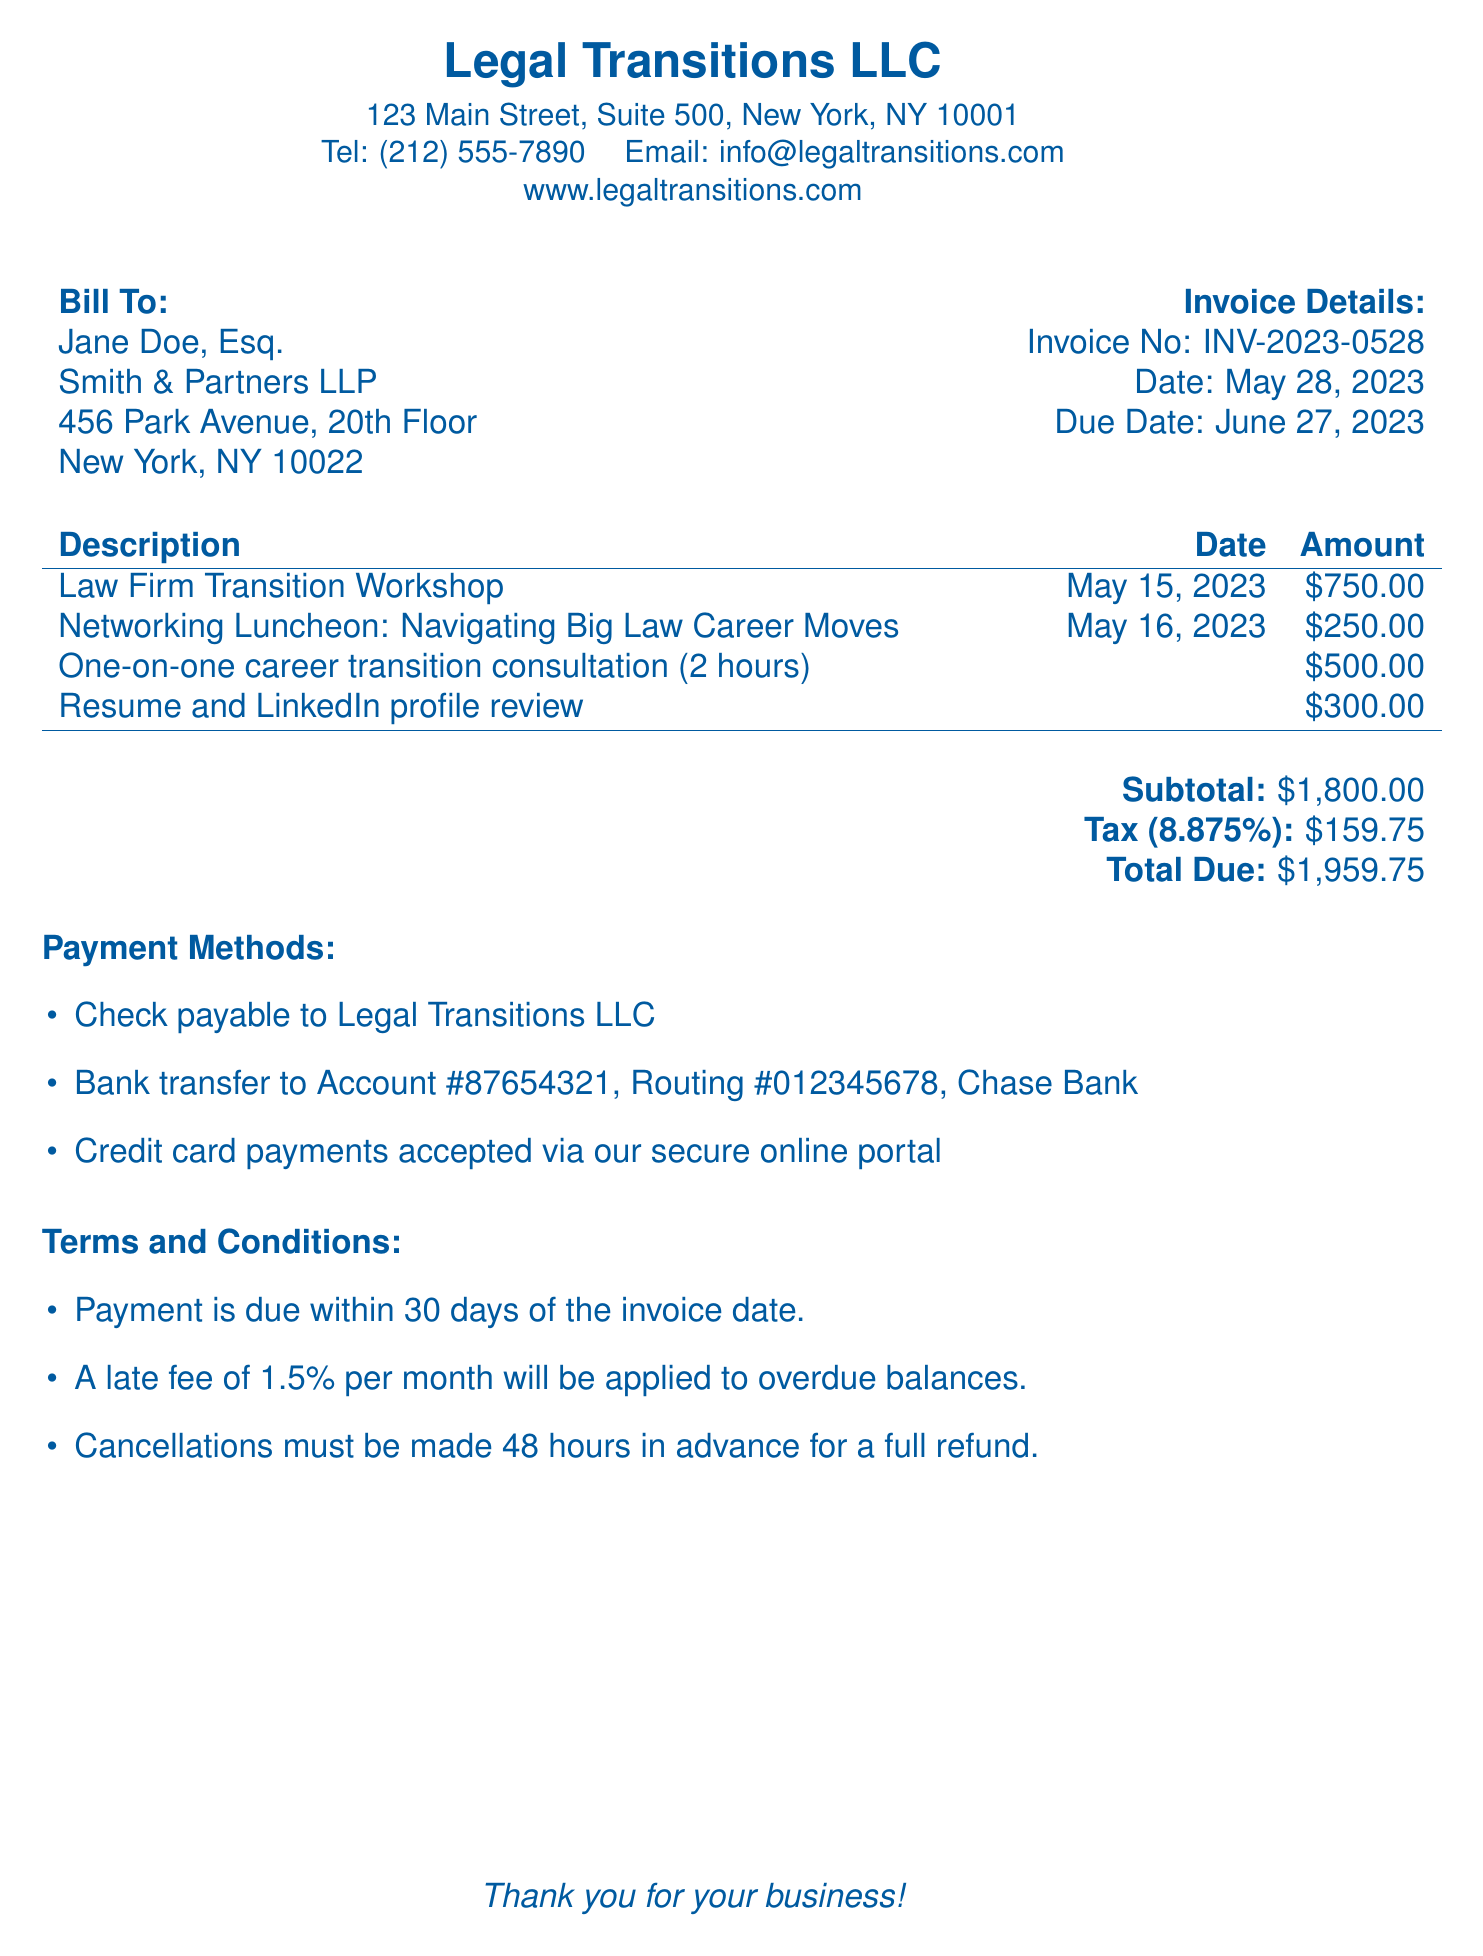What is the invoice number? The invoice number is found in the invoice details section of the document.
Answer: INV-2023-0528 Who is the bill recipient? The bill recipient is the individual or entity listed in the "Bill To" section.
Answer: Jane Doe, Esq What is the total amount due? The total amount due is calculated at the end of the invoice after adding the subtotal and tax.
Answer: $1,959.75 When is the due date for payment? The due date is specified in the invoice details section.
Answer: June 27, 2023 What is the amount for the Law Firm Transition Workshop? The amount for the workshop is listed under the description section.
Answer: $750.00 What is the tax rate applied to the subtotal? The tax rate can be found alongside the tax calculation in the document.
Answer: 8.875% What is the payment method that involves a credit card? This payment method is indicated in the payment methods section.
Answer: Secure online portal What is the late fee percentage for overdue balances? The late fee percentage is mentioned in the terms and conditions section.
Answer: 1.5% How many hours are included in the career transition consultation? The number of hours can be found in the description of that service.
Answer: 2 hours 